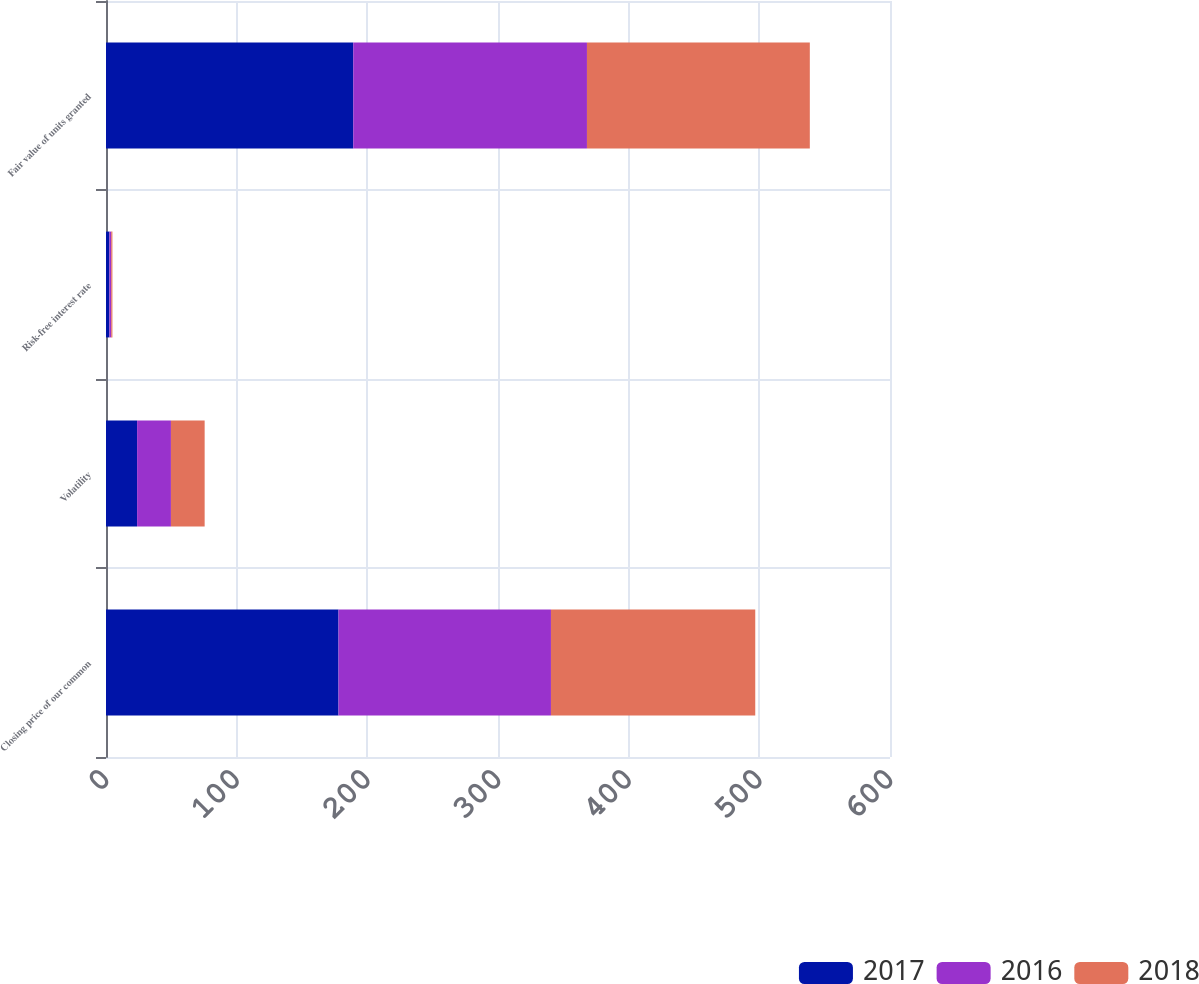<chart> <loc_0><loc_0><loc_500><loc_500><stacked_bar_chart><ecel><fcel>Closing price of our common<fcel>Volatility<fcel>Risk-free interest rate<fcel>Fair value of units granted<nl><fcel>2017<fcel>177.93<fcel>23.8<fcel>2.6<fcel>189.21<nl><fcel>2016<fcel>162.6<fcel>25.9<fcel>1.4<fcel>178.87<nl><fcel>2018<fcel>156.35<fcel>25.8<fcel>0.9<fcel>170.56<nl></chart> 